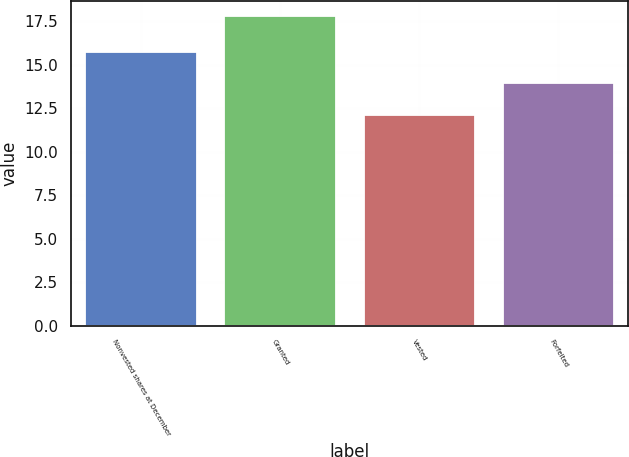<chart> <loc_0><loc_0><loc_500><loc_500><bar_chart><fcel>Nonvested shares at December<fcel>Granted<fcel>Vested<fcel>Forfeited<nl><fcel>15.7<fcel>17.79<fcel>12.08<fcel>13.95<nl></chart> 